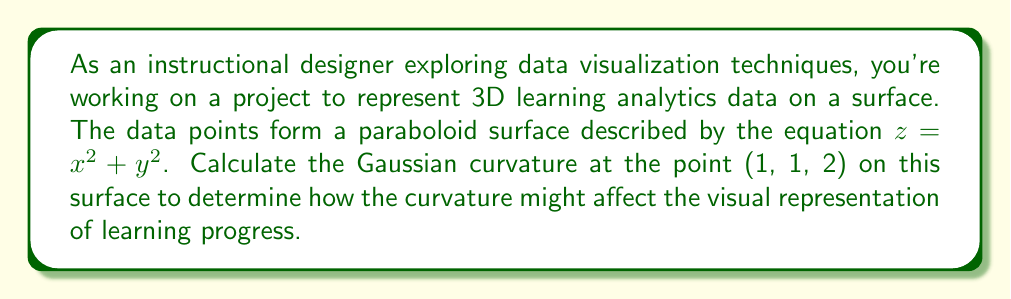Can you solve this math problem? To calculate the Gaussian curvature of the paraboloid surface $z = x^2 + y^2$ at the point (1, 1, 2), we'll follow these steps:

1. Identify the surface equation:
   $f(x,y) = x^2 + y^2$

2. Calculate the partial derivatives:
   $f_x = 2x$
   $f_y = 2y$
   $f_{xx} = 2$
   $f_{yy} = 2$
   $f_{xy} = f_{yx} = 0$

3. Calculate the components of the first fundamental form:
   $E = 1 + f_x^2 = 1 + (2x)^2 = 1 + 4x^2$
   $F = f_x f_y = (2x)(2y) = 4xy$
   $G = 1 + f_y^2 = 1 + (2y)^2 = 1 + 4y^2$

4. Calculate the components of the second fundamental form:
   $L = \frac{f_{xx}}{\sqrt{1 + f_x^2 + f_y^2}} = \frac{2}{\sqrt{1 + 4x^2 + 4y^2}}$
   $M = \frac{f_{xy}}{\sqrt{1 + f_x^2 + f_y^2}} = 0$
   $N = \frac{f_{yy}}{\sqrt{1 + f_x^2 + f_y^2}} = \frac{2}{\sqrt{1 + 4x^2 + 4y^2}}$

5. Calculate the Gaussian curvature using the formula:
   $K = \frac{LN - M^2}{EG - F^2}$

6. Substitute the values at the point (1, 1, 2):
   $K = \frac{(\frac{2}{\sqrt{1 + 4 + 4}})(\frac{2}{\sqrt{1 + 4 + 4}}) - 0^2}{(1 + 4)(1 + 4) - (4)^2}$

7. Simplify:
   $K = \frac{(\frac{2}{\sqrt{9}})(\frac{2}{\sqrt{9}})}{25 - 16} = \frac{(\frac{2}{3})(\frac{2}{3})}{9} = \frac{4}{81}$

Therefore, the Gaussian curvature at the point (1, 1, 2) is $\frac{4}{81}$.
Answer: $\frac{4}{81}$ 